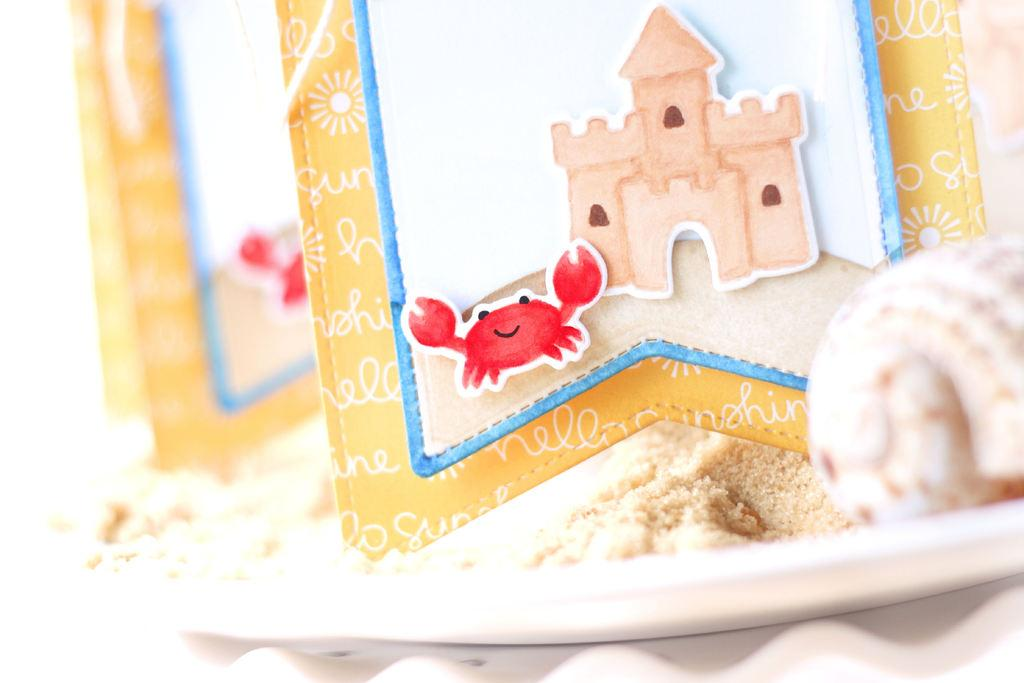What is on the plate in the image? There is a food item on the plate in the image. What can be seen in the background of the image? There are cards in the background of the image. What images are on the cards? The cards have a crab image and a house image. What type of plants can be seen growing on the plate in the image? There are no plants visible on the plate in the image; it contains a food item. 